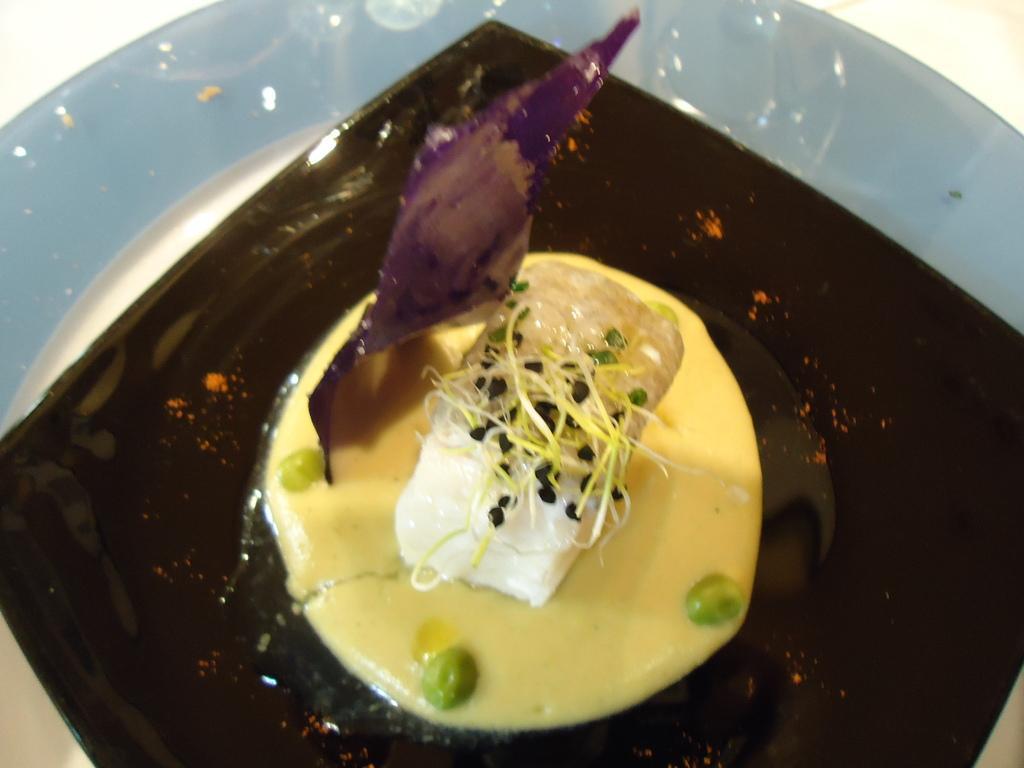Can you describe this image briefly? In this image we can see food placed in a plate. 